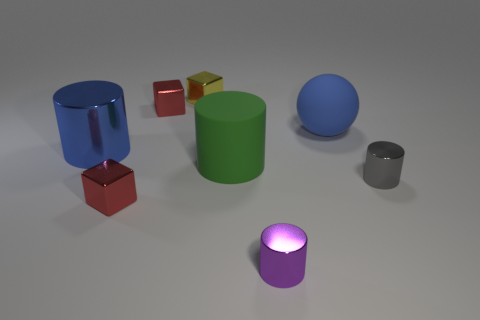There is a cylinder that is in front of the gray object; how big is it?
Your answer should be very brief. Small. There is a large shiny thing; is it the same color as the large cylinder on the right side of the tiny yellow thing?
Provide a succinct answer. No. How many other things are the same material as the gray cylinder?
Give a very brief answer. 5. Is the number of large balls greater than the number of cubes?
Give a very brief answer. No. There is a metallic cylinder that is in front of the small gray metallic cylinder; is it the same color as the sphere?
Your answer should be very brief. No. What color is the big shiny cylinder?
Provide a succinct answer. Blue. Is there a red shiny cube that is left of the object to the right of the matte sphere?
Ensure brevity in your answer.  Yes. The small red thing that is behind the tiny red metal thing in front of the large blue metal cylinder is what shape?
Provide a short and direct response. Cube. Is the number of cylinders less than the number of yellow cubes?
Make the answer very short. No. Does the big blue sphere have the same material as the gray thing?
Give a very brief answer. No. 